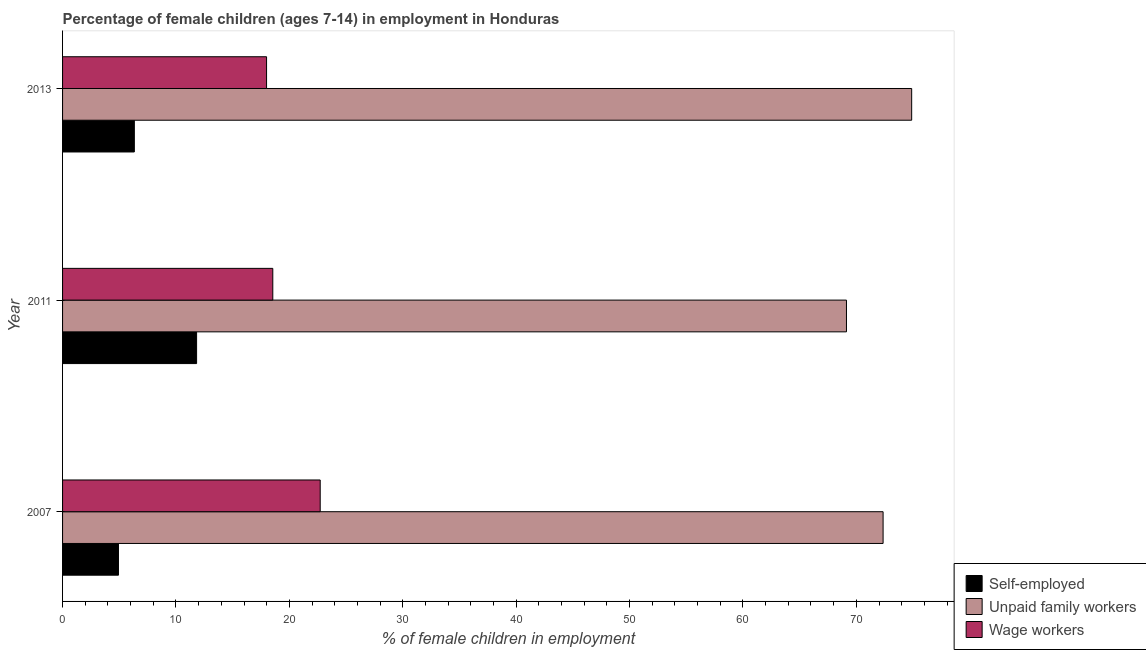How many groups of bars are there?
Your answer should be very brief. 3. Are the number of bars per tick equal to the number of legend labels?
Your answer should be very brief. Yes. Are the number of bars on each tick of the Y-axis equal?
Your response must be concise. Yes. How many bars are there on the 3rd tick from the top?
Your answer should be very brief. 3. How many bars are there on the 2nd tick from the bottom?
Provide a succinct answer. 3. In how many cases, is the number of bars for a given year not equal to the number of legend labels?
Your answer should be very brief. 0. What is the percentage of self employed children in 2013?
Give a very brief answer. 6.33. Across all years, what is the maximum percentage of children employed as wage workers?
Your response must be concise. 22.72. Across all years, what is the minimum percentage of children employed as wage workers?
Provide a succinct answer. 17.99. What is the total percentage of children employed as wage workers in the graph?
Make the answer very short. 59.25. What is the difference between the percentage of children employed as wage workers in 2011 and that in 2013?
Provide a succinct answer. 0.55. What is the difference between the percentage of self employed children in 2007 and the percentage of children employed as unpaid family workers in 2013?
Ensure brevity in your answer.  -69.95. What is the average percentage of self employed children per year?
Your answer should be compact. 7.69. In the year 2007, what is the difference between the percentage of children employed as wage workers and percentage of self employed children?
Offer a terse response. 17.79. In how many years, is the percentage of children employed as wage workers greater than 6 %?
Provide a short and direct response. 3. What is the ratio of the percentage of children employed as unpaid family workers in 2007 to that in 2013?
Offer a very short reply. 0.97. What is the difference between the highest and the second highest percentage of children employed as unpaid family workers?
Give a very brief answer. 2.52. What is the difference between the highest and the lowest percentage of children employed as unpaid family workers?
Your answer should be very brief. 5.75. What does the 1st bar from the top in 2011 represents?
Offer a terse response. Wage workers. What does the 1st bar from the bottom in 2013 represents?
Your response must be concise. Self-employed. Is it the case that in every year, the sum of the percentage of self employed children and percentage of children employed as unpaid family workers is greater than the percentage of children employed as wage workers?
Your answer should be very brief. Yes. How many years are there in the graph?
Keep it short and to the point. 3. Does the graph contain grids?
Keep it short and to the point. No. Where does the legend appear in the graph?
Make the answer very short. Bottom right. How many legend labels are there?
Give a very brief answer. 3. What is the title of the graph?
Your response must be concise. Percentage of female children (ages 7-14) in employment in Honduras. What is the label or title of the X-axis?
Provide a short and direct response. % of female children in employment. What is the % of female children in employment in Self-employed in 2007?
Provide a succinct answer. 4.93. What is the % of female children in employment of Unpaid family workers in 2007?
Provide a succinct answer. 72.36. What is the % of female children in employment in Wage workers in 2007?
Your response must be concise. 22.72. What is the % of female children in employment of Self-employed in 2011?
Keep it short and to the point. 11.82. What is the % of female children in employment in Unpaid family workers in 2011?
Provide a short and direct response. 69.13. What is the % of female children in employment of Wage workers in 2011?
Provide a succinct answer. 18.54. What is the % of female children in employment of Self-employed in 2013?
Offer a very short reply. 6.33. What is the % of female children in employment of Unpaid family workers in 2013?
Your answer should be very brief. 74.88. What is the % of female children in employment in Wage workers in 2013?
Make the answer very short. 17.99. Across all years, what is the maximum % of female children in employment in Self-employed?
Ensure brevity in your answer.  11.82. Across all years, what is the maximum % of female children in employment in Unpaid family workers?
Keep it short and to the point. 74.88. Across all years, what is the maximum % of female children in employment of Wage workers?
Provide a succinct answer. 22.72. Across all years, what is the minimum % of female children in employment of Self-employed?
Provide a succinct answer. 4.93. Across all years, what is the minimum % of female children in employment in Unpaid family workers?
Your answer should be very brief. 69.13. Across all years, what is the minimum % of female children in employment in Wage workers?
Give a very brief answer. 17.99. What is the total % of female children in employment of Self-employed in the graph?
Give a very brief answer. 23.08. What is the total % of female children in employment in Unpaid family workers in the graph?
Your response must be concise. 216.37. What is the total % of female children in employment in Wage workers in the graph?
Your response must be concise. 59.25. What is the difference between the % of female children in employment of Self-employed in 2007 and that in 2011?
Your response must be concise. -6.89. What is the difference between the % of female children in employment of Unpaid family workers in 2007 and that in 2011?
Make the answer very short. 3.23. What is the difference between the % of female children in employment in Wage workers in 2007 and that in 2011?
Keep it short and to the point. 4.18. What is the difference between the % of female children in employment of Self-employed in 2007 and that in 2013?
Offer a terse response. -1.4. What is the difference between the % of female children in employment of Unpaid family workers in 2007 and that in 2013?
Give a very brief answer. -2.52. What is the difference between the % of female children in employment in Wage workers in 2007 and that in 2013?
Give a very brief answer. 4.73. What is the difference between the % of female children in employment in Self-employed in 2011 and that in 2013?
Ensure brevity in your answer.  5.49. What is the difference between the % of female children in employment in Unpaid family workers in 2011 and that in 2013?
Give a very brief answer. -5.75. What is the difference between the % of female children in employment of Wage workers in 2011 and that in 2013?
Your answer should be compact. 0.55. What is the difference between the % of female children in employment of Self-employed in 2007 and the % of female children in employment of Unpaid family workers in 2011?
Offer a terse response. -64.2. What is the difference between the % of female children in employment in Self-employed in 2007 and the % of female children in employment in Wage workers in 2011?
Make the answer very short. -13.61. What is the difference between the % of female children in employment in Unpaid family workers in 2007 and the % of female children in employment in Wage workers in 2011?
Provide a succinct answer. 53.82. What is the difference between the % of female children in employment of Self-employed in 2007 and the % of female children in employment of Unpaid family workers in 2013?
Provide a short and direct response. -69.95. What is the difference between the % of female children in employment of Self-employed in 2007 and the % of female children in employment of Wage workers in 2013?
Give a very brief answer. -13.06. What is the difference between the % of female children in employment in Unpaid family workers in 2007 and the % of female children in employment in Wage workers in 2013?
Ensure brevity in your answer.  54.37. What is the difference between the % of female children in employment in Self-employed in 2011 and the % of female children in employment in Unpaid family workers in 2013?
Your answer should be very brief. -63.06. What is the difference between the % of female children in employment of Self-employed in 2011 and the % of female children in employment of Wage workers in 2013?
Give a very brief answer. -6.17. What is the difference between the % of female children in employment of Unpaid family workers in 2011 and the % of female children in employment of Wage workers in 2013?
Your answer should be very brief. 51.14. What is the average % of female children in employment of Self-employed per year?
Your answer should be very brief. 7.69. What is the average % of female children in employment in Unpaid family workers per year?
Your answer should be compact. 72.12. What is the average % of female children in employment in Wage workers per year?
Ensure brevity in your answer.  19.75. In the year 2007, what is the difference between the % of female children in employment in Self-employed and % of female children in employment in Unpaid family workers?
Provide a short and direct response. -67.43. In the year 2007, what is the difference between the % of female children in employment in Self-employed and % of female children in employment in Wage workers?
Provide a succinct answer. -17.79. In the year 2007, what is the difference between the % of female children in employment in Unpaid family workers and % of female children in employment in Wage workers?
Make the answer very short. 49.64. In the year 2011, what is the difference between the % of female children in employment in Self-employed and % of female children in employment in Unpaid family workers?
Your answer should be compact. -57.31. In the year 2011, what is the difference between the % of female children in employment of Self-employed and % of female children in employment of Wage workers?
Provide a short and direct response. -6.72. In the year 2011, what is the difference between the % of female children in employment in Unpaid family workers and % of female children in employment in Wage workers?
Provide a short and direct response. 50.59. In the year 2013, what is the difference between the % of female children in employment of Self-employed and % of female children in employment of Unpaid family workers?
Your answer should be compact. -68.55. In the year 2013, what is the difference between the % of female children in employment of Self-employed and % of female children in employment of Wage workers?
Keep it short and to the point. -11.66. In the year 2013, what is the difference between the % of female children in employment in Unpaid family workers and % of female children in employment in Wage workers?
Make the answer very short. 56.89. What is the ratio of the % of female children in employment of Self-employed in 2007 to that in 2011?
Offer a very short reply. 0.42. What is the ratio of the % of female children in employment of Unpaid family workers in 2007 to that in 2011?
Ensure brevity in your answer.  1.05. What is the ratio of the % of female children in employment of Wage workers in 2007 to that in 2011?
Keep it short and to the point. 1.23. What is the ratio of the % of female children in employment in Self-employed in 2007 to that in 2013?
Your answer should be compact. 0.78. What is the ratio of the % of female children in employment in Unpaid family workers in 2007 to that in 2013?
Your answer should be compact. 0.97. What is the ratio of the % of female children in employment of Wage workers in 2007 to that in 2013?
Your answer should be very brief. 1.26. What is the ratio of the % of female children in employment of Self-employed in 2011 to that in 2013?
Offer a terse response. 1.87. What is the ratio of the % of female children in employment in Unpaid family workers in 2011 to that in 2013?
Provide a short and direct response. 0.92. What is the ratio of the % of female children in employment in Wage workers in 2011 to that in 2013?
Your response must be concise. 1.03. What is the difference between the highest and the second highest % of female children in employment in Self-employed?
Offer a terse response. 5.49. What is the difference between the highest and the second highest % of female children in employment of Unpaid family workers?
Ensure brevity in your answer.  2.52. What is the difference between the highest and the second highest % of female children in employment of Wage workers?
Provide a succinct answer. 4.18. What is the difference between the highest and the lowest % of female children in employment of Self-employed?
Provide a short and direct response. 6.89. What is the difference between the highest and the lowest % of female children in employment of Unpaid family workers?
Provide a succinct answer. 5.75. What is the difference between the highest and the lowest % of female children in employment of Wage workers?
Provide a succinct answer. 4.73. 